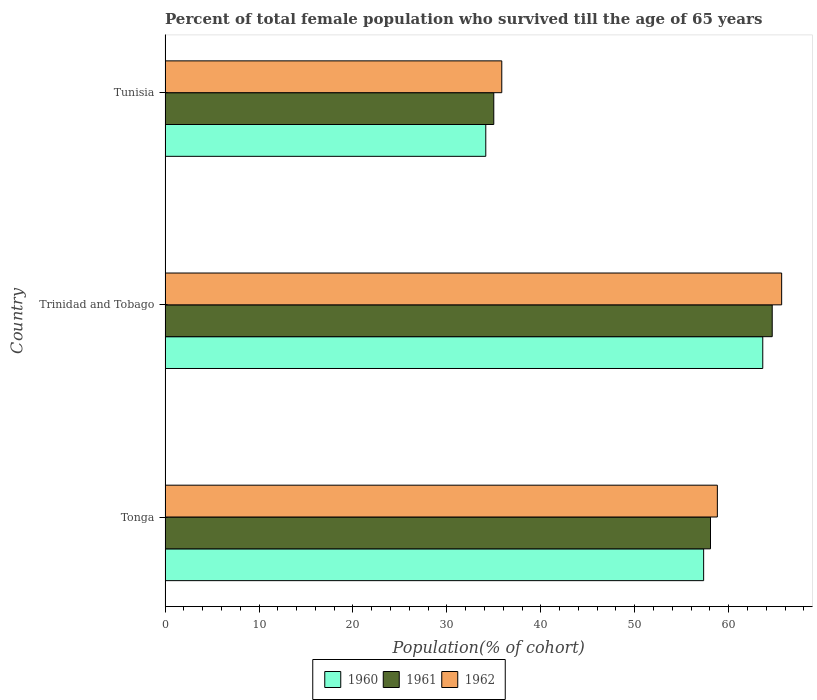How many different coloured bars are there?
Your response must be concise. 3. How many groups of bars are there?
Offer a terse response. 3. Are the number of bars per tick equal to the number of legend labels?
Your answer should be very brief. Yes. Are the number of bars on each tick of the Y-axis equal?
Your answer should be very brief. Yes. How many bars are there on the 3rd tick from the top?
Give a very brief answer. 3. What is the label of the 2nd group of bars from the top?
Make the answer very short. Trinidad and Tobago. In how many cases, is the number of bars for a given country not equal to the number of legend labels?
Offer a very short reply. 0. What is the percentage of total female population who survived till the age of 65 years in 1960 in Trinidad and Tobago?
Your answer should be compact. 63.63. Across all countries, what is the maximum percentage of total female population who survived till the age of 65 years in 1961?
Your answer should be very brief. 64.63. Across all countries, what is the minimum percentage of total female population who survived till the age of 65 years in 1961?
Your answer should be compact. 34.99. In which country was the percentage of total female population who survived till the age of 65 years in 1961 maximum?
Offer a terse response. Trinidad and Tobago. In which country was the percentage of total female population who survived till the age of 65 years in 1962 minimum?
Give a very brief answer. Tunisia. What is the total percentage of total female population who survived till the age of 65 years in 1961 in the graph?
Your answer should be compact. 157.69. What is the difference between the percentage of total female population who survived till the age of 65 years in 1962 in Tonga and that in Trinidad and Tobago?
Your answer should be very brief. -6.85. What is the difference between the percentage of total female population who survived till the age of 65 years in 1961 in Tonga and the percentage of total female population who survived till the age of 65 years in 1962 in Tunisia?
Your response must be concise. 22.22. What is the average percentage of total female population who survived till the age of 65 years in 1961 per country?
Ensure brevity in your answer.  52.56. What is the difference between the percentage of total female population who survived till the age of 65 years in 1962 and percentage of total female population who survived till the age of 65 years in 1961 in Tunisia?
Offer a terse response. 0.85. In how many countries, is the percentage of total female population who survived till the age of 65 years in 1960 greater than 38 %?
Your response must be concise. 2. What is the ratio of the percentage of total female population who survived till the age of 65 years in 1960 in Tonga to that in Trinidad and Tobago?
Ensure brevity in your answer.  0.9. What is the difference between the highest and the second highest percentage of total female population who survived till the age of 65 years in 1961?
Ensure brevity in your answer.  6.57. What is the difference between the highest and the lowest percentage of total female population who survived till the age of 65 years in 1962?
Offer a very short reply. 29.8. In how many countries, is the percentage of total female population who survived till the age of 65 years in 1961 greater than the average percentage of total female population who survived till the age of 65 years in 1961 taken over all countries?
Provide a succinct answer. 2. What does the 1st bar from the top in Trinidad and Tobago represents?
Offer a terse response. 1962. What does the 1st bar from the bottom in Trinidad and Tobago represents?
Make the answer very short. 1960. What is the difference between two consecutive major ticks on the X-axis?
Your answer should be compact. 10. Are the values on the major ticks of X-axis written in scientific E-notation?
Your response must be concise. No. Does the graph contain any zero values?
Your answer should be compact. No. Where does the legend appear in the graph?
Give a very brief answer. Bottom center. How are the legend labels stacked?
Keep it short and to the point. Horizontal. What is the title of the graph?
Your answer should be very brief. Percent of total female population who survived till the age of 65 years. What is the label or title of the X-axis?
Your answer should be very brief. Population(% of cohort). What is the Population(% of cohort) of 1960 in Tonga?
Provide a short and direct response. 57.33. What is the Population(% of cohort) of 1961 in Tonga?
Offer a very short reply. 58.06. What is the Population(% of cohort) in 1962 in Tonga?
Ensure brevity in your answer.  58.79. What is the Population(% of cohort) of 1960 in Trinidad and Tobago?
Provide a short and direct response. 63.63. What is the Population(% of cohort) in 1961 in Trinidad and Tobago?
Ensure brevity in your answer.  64.63. What is the Population(% of cohort) of 1962 in Trinidad and Tobago?
Give a very brief answer. 65.64. What is the Population(% of cohort) of 1960 in Tunisia?
Give a very brief answer. 34.14. What is the Population(% of cohort) in 1961 in Tunisia?
Provide a short and direct response. 34.99. What is the Population(% of cohort) in 1962 in Tunisia?
Your answer should be compact. 35.84. Across all countries, what is the maximum Population(% of cohort) in 1960?
Your response must be concise. 63.63. Across all countries, what is the maximum Population(% of cohort) of 1961?
Provide a short and direct response. 64.63. Across all countries, what is the maximum Population(% of cohort) of 1962?
Make the answer very short. 65.64. Across all countries, what is the minimum Population(% of cohort) in 1960?
Your answer should be very brief. 34.14. Across all countries, what is the minimum Population(% of cohort) in 1961?
Your answer should be very brief. 34.99. Across all countries, what is the minimum Population(% of cohort) of 1962?
Give a very brief answer. 35.84. What is the total Population(% of cohort) of 1960 in the graph?
Make the answer very short. 155.1. What is the total Population(% of cohort) in 1961 in the graph?
Keep it short and to the point. 157.69. What is the total Population(% of cohort) of 1962 in the graph?
Give a very brief answer. 160.28. What is the difference between the Population(% of cohort) in 1960 in Tonga and that in Trinidad and Tobago?
Offer a very short reply. -6.29. What is the difference between the Population(% of cohort) in 1961 in Tonga and that in Trinidad and Tobago?
Provide a short and direct response. -6.57. What is the difference between the Population(% of cohort) in 1962 in Tonga and that in Trinidad and Tobago?
Your answer should be compact. -6.85. What is the difference between the Population(% of cohort) in 1960 in Tonga and that in Tunisia?
Your response must be concise. 23.19. What is the difference between the Population(% of cohort) of 1961 in Tonga and that in Tunisia?
Your response must be concise. 23.07. What is the difference between the Population(% of cohort) in 1962 in Tonga and that in Tunisia?
Provide a short and direct response. 22.95. What is the difference between the Population(% of cohort) of 1960 in Trinidad and Tobago and that in Tunisia?
Provide a short and direct response. 29.49. What is the difference between the Population(% of cohort) of 1961 in Trinidad and Tobago and that in Tunisia?
Ensure brevity in your answer.  29.64. What is the difference between the Population(% of cohort) in 1962 in Trinidad and Tobago and that in Tunisia?
Keep it short and to the point. 29.8. What is the difference between the Population(% of cohort) of 1960 in Tonga and the Population(% of cohort) of 1961 in Trinidad and Tobago?
Ensure brevity in your answer.  -7.3. What is the difference between the Population(% of cohort) in 1960 in Tonga and the Population(% of cohort) in 1962 in Trinidad and Tobago?
Provide a succinct answer. -8.31. What is the difference between the Population(% of cohort) of 1961 in Tonga and the Population(% of cohort) of 1962 in Trinidad and Tobago?
Make the answer very short. -7.58. What is the difference between the Population(% of cohort) in 1960 in Tonga and the Population(% of cohort) in 1961 in Tunisia?
Offer a terse response. 22.34. What is the difference between the Population(% of cohort) of 1960 in Tonga and the Population(% of cohort) of 1962 in Tunisia?
Provide a succinct answer. 21.49. What is the difference between the Population(% of cohort) of 1961 in Tonga and the Population(% of cohort) of 1962 in Tunisia?
Offer a very short reply. 22.22. What is the difference between the Population(% of cohort) of 1960 in Trinidad and Tobago and the Population(% of cohort) of 1961 in Tunisia?
Your answer should be very brief. 28.64. What is the difference between the Population(% of cohort) in 1960 in Trinidad and Tobago and the Population(% of cohort) in 1962 in Tunisia?
Provide a short and direct response. 27.79. What is the difference between the Population(% of cohort) of 1961 in Trinidad and Tobago and the Population(% of cohort) of 1962 in Tunisia?
Your answer should be compact. 28.79. What is the average Population(% of cohort) of 1960 per country?
Offer a very short reply. 51.7. What is the average Population(% of cohort) in 1961 per country?
Give a very brief answer. 52.56. What is the average Population(% of cohort) in 1962 per country?
Your answer should be very brief. 53.43. What is the difference between the Population(% of cohort) of 1960 and Population(% of cohort) of 1961 in Tonga?
Your response must be concise. -0.73. What is the difference between the Population(% of cohort) in 1960 and Population(% of cohort) in 1962 in Tonga?
Provide a succinct answer. -1.46. What is the difference between the Population(% of cohort) of 1961 and Population(% of cohort) of 1962 in Tonga?
Give a very brief answer. -0.73. What is the difference between the Population(% of cohort) in 1960 and Population(% of cohort) in 1961 in Trinidad and Tobago?
Your answer should be very brief. -1.01. What is the difference between the Population(% of cohort) in 1960 and Population(% of cohort) in 1962 in Trinidad and Tobago?
Provide a short and direct response. -2.01. What is the difference between the Population(% of cohort) in 1961 and Population(% of cohort) in 1962 in Trinidad and Tobago?
Keep it short and to the point. -1.01. What is the difference between the Population(% of cohort) of 1960 and Population(% of cohort) of 1961 in Tunisia?
Your answer should be compact. -0.85. What is the difference between the Population(% of cohort) of 1960 and Population(% of cohort) of 1962 in Tunisia?
Your response must be concise. -1.7. What is the difference between the Population(% of cohort) of 1961 and Population(% of cohort) of 1962 in Tunisia?
Offer a terse response. -0.85. What is the ratio of the Population(% of cohort) of 1960 in Tonga to that in Trinidad and Tobago?
Give a very brief answer. 0.9. What is the ratio of the Population(% of cohort) in 1961 in Tonga to that in Trinidad and Tobago?
Offer a very short reply. 0.9. What is the ratio of the Population(% of cohort) of 1962 in Tonga to that in Trinidad and Tobago?
Your answer should be very brief. 0.9. What is the ratio of the Population(% of cohort) of 1960 in Tonga to that in Tunisia?
Ensure brevity in your answer.  1.68. What is the ratio of the Population(% of cohort) in 1961 in Tonga to that in Tunisia?
Your answer should be very brief. 1.66. What is the ratio of the Population(% of cohort) of 1962 in Tonga to that in Tunisia?
Make the answer very short. 1.64. What is the ratio of the Population(% of cohort) of 1960 in Trinidad and Tobago to that in Tunisia?
Keep it short and to the point. 1.86. What is the ratio of the Population(% of cohort) in 1961 in Trinidad and Tobago to that in Tunisia?
Your response must be concise. 1.85. What is the ratio of the Population(% of cohort) in 1962 in Trinidad and Tobago to that in Tunisia?
Ensure brevity in your answer.  1.83. What is the difference between the highest and the second highest Population(% of cohort) in 1960?
Provide a succinct answer. 6.29. What is the difference between the highest and the second highest Population(% of cohort) of 1961?
Make the answer very short. 6.57. What is the difference between the highest and the second highest Population(% of cohort) of 1962?
Offer a very short reply. 6.85. What is the difference between the highest and the lowest Population(% of cohort) of 1960?
Keep it short and to the point. 29.49. What is the difference between the highest and the lowest Population(% of cohort) of 1961?
Offer a very short reply. 29.64. What is the difference between the highest and the lowest Population(% of cohort) of 1962?
Make the answer very short. 29.8. 